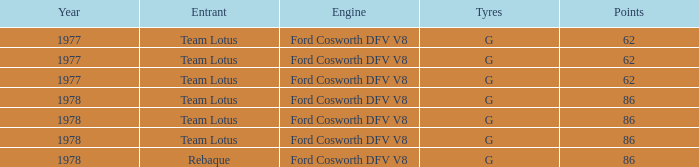What is the Focus that has a Year bigger than 1977? 86, 86, 86, 86. 